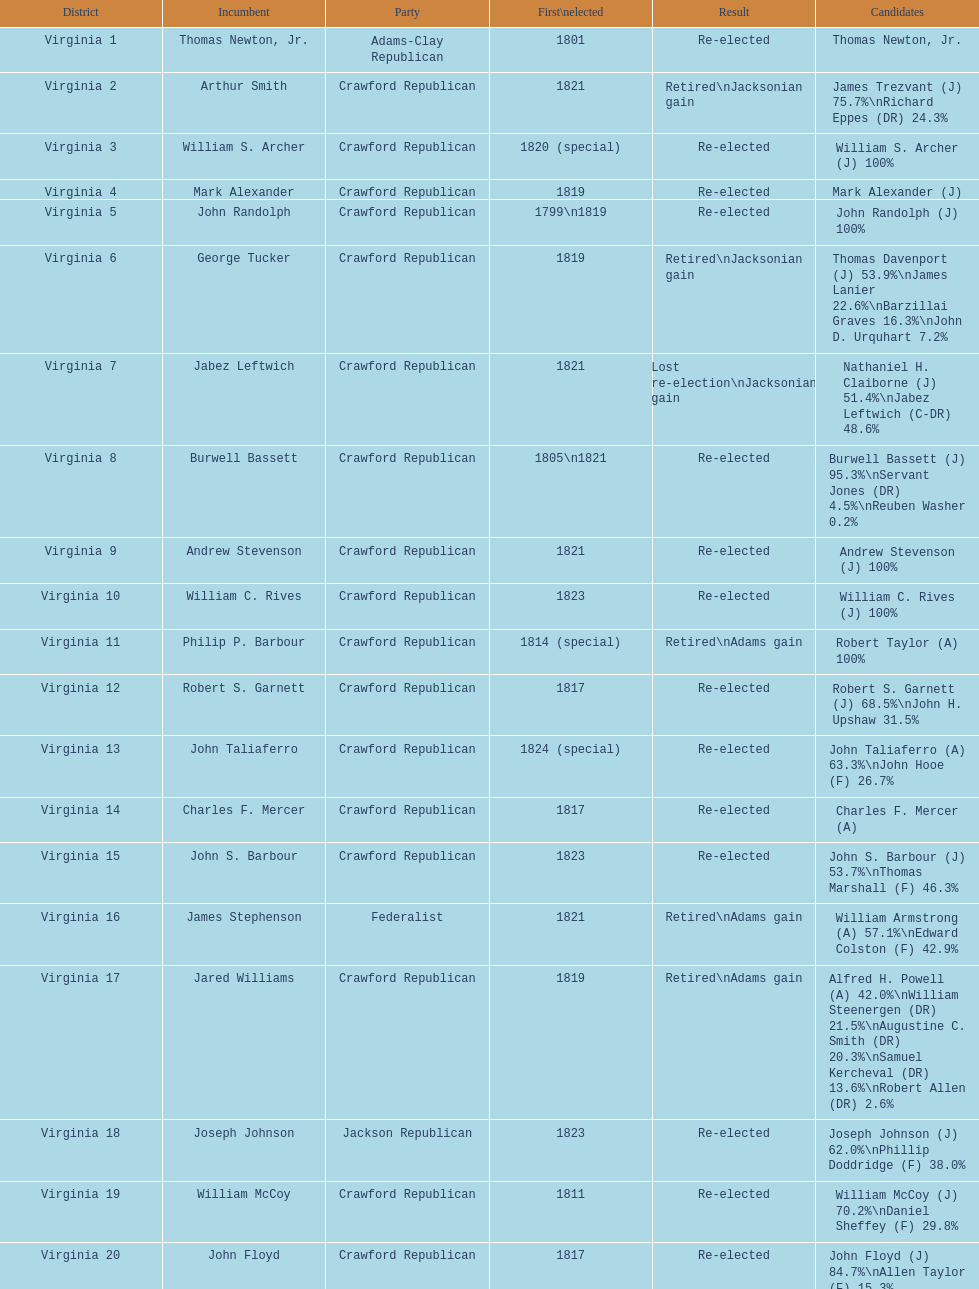Who was the next incumbent after john randolph? George Tucker. 